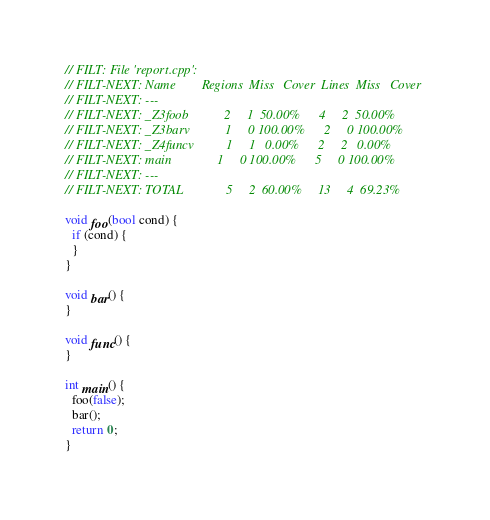<code> <loc_0><loc_0><loc_500><loc_500><_C++_>// FILT: File 'report.cpp':
// FILT-NEXT: Name        Regions  Miss   Cover  Lines  Miss   Cover
// FILT-NEXT: ---
// FILT-NEXT: _Z3foob           2     1  50.00%      4     2  50.00%
// FILT-NEXT: _Z3barv           1     0 100.00%      2     0 100.00%
// FILT-NEXT: _Z4funcv          1     1   0.00%      2     2   0.00%
// FILT-NEXT: main              1     0 100.00%      5     0 100.00%
// FILT-NEXT: ---
// FILT-NEXT: TOTAL             5     2  60.00%     13     4  69.23%

void foo(bool cond) {
  if (cond) {
  }
}

void bar() {
}

void func() {
}

int main() {
  foo(false);
  bar();
  return 0;
}
</code> 